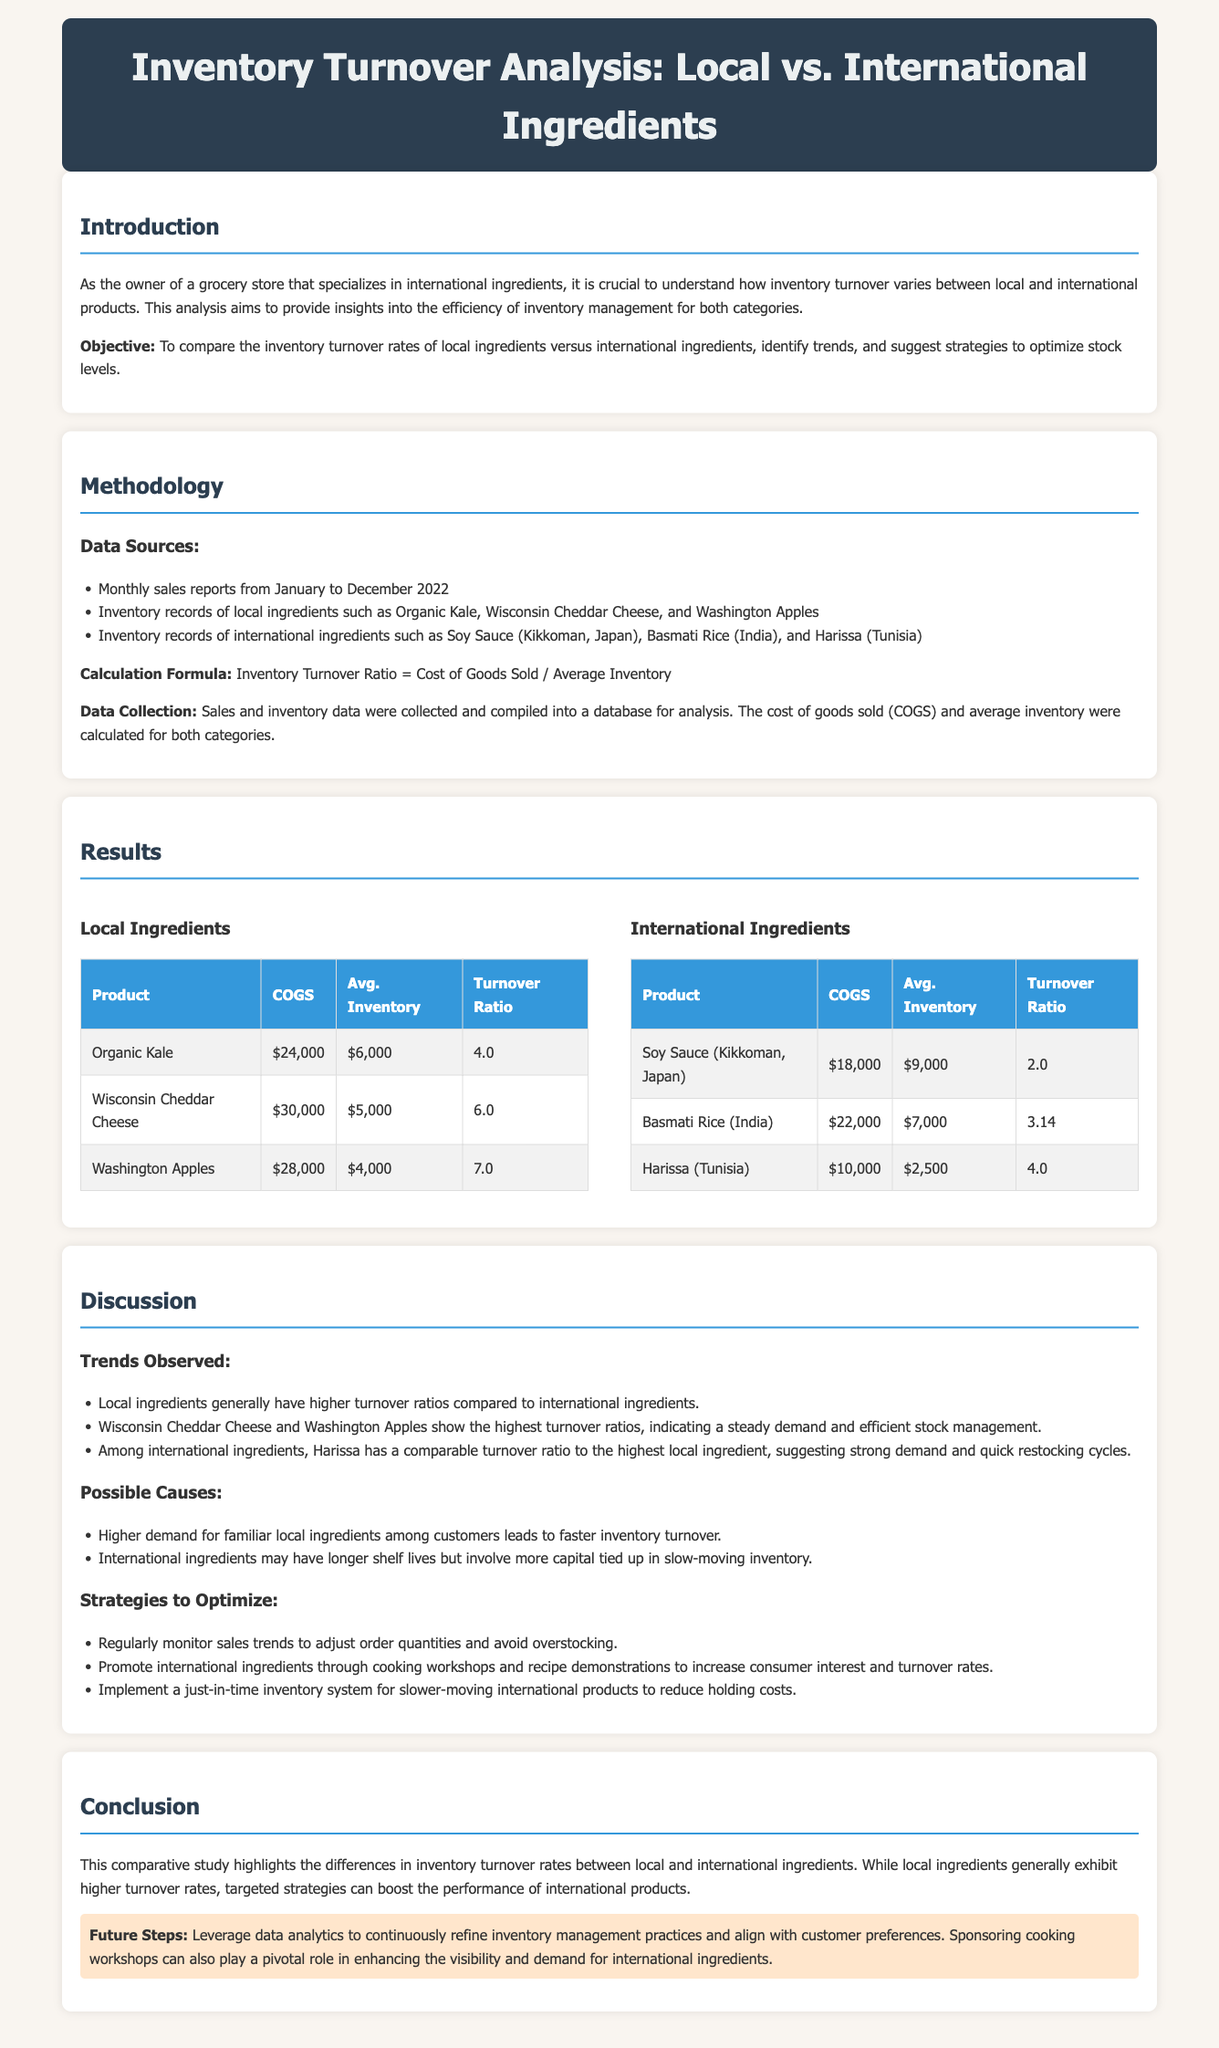What is the objective of the study? The objective is to compare the inventory turnover rates of local ingredients versus international ingredients, identify trends, and suggest strategies to optimize stock levels.
Answer: To compare inventory turnover rates What product has the highest turnover ratio among local ingredients? According to the results section, Washington Apples have the highest turnover ratio among local ingredients.
Answer: Washington Apples What is the turnover ratio for Harissa (Tunisia)? The results show that Harissa has a turnover ratio of 4.0.
Answer: 4.0 What are the data sources mentioned in the methodology? The data sources include monthly sales reports from January to December 2022 and inventory records for local and international ingredients.
Answer: Monthly sales reports, inventory records According to the discussion, what is a possible cause of higher turnover for local ingredients? The document states that higher demand for familiar local ingredients among customers leads to faster inventory turnover.
Answer: Higher demand for familiar local ingredients What is one strategy suggested to optimize international ingredient performance? The document suggests promoting international ingredients through cooking workshops and recipe demonstrations to increase consumer interest.
Answer: Promote through cooking workshops What was the main document type for this report? The report is classified as a lab report focused on inventory turnover analysis.
Answer: Lab report What month range does the sales data cover? The sales data covers the period from January to December 2022.
Answer: January to December 2022 